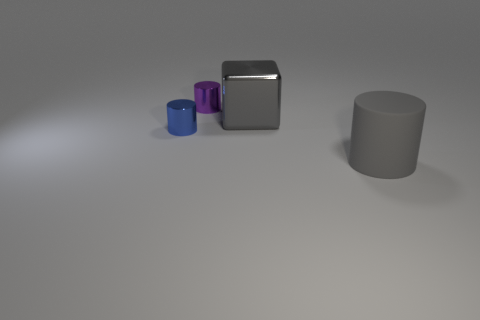Is the number of matte things that are left of the blue shiny cylinder greater than the number of cylinders that are left of the tiny purple object?
Your response must be concise. No. Is the small cylinder behind the large gray metallic object made of the same material as the large object that is behind the tiny blue cylinder?
Make the answer very short. Yes. There is a tiny purple metal thing; are there any tiny purple things on the right side of it?
Provide a succinct answer. No. How many blue things are small metal cylinders or shiny cubes?
Ensure brevity in your answer.  1. Is the material of the purple cylinder the same as the gray object in front of the tiny blue shiny cylinder?
Your response must be concise. No. There is a blue object that is the same shape as the purple shiny thing; what size is it?
Your response must be concise. Small. What is the material of the small blue object?
Ensure brevity in your answer.  Metal. There is a gray cube that is to the left of the large thing that is in front of the tiny cylinder that is in front of the gray cube; what is its material?
Provide a succinct answer. Metal. Is the size of the metallic cube that is to the right of the tiny blue object the same as the purple thing that is behind the big matte thing?
Ensure brevity in your answer.  No. What number of other things are there of the same material as the gray block
Provide a short and direct response. 2. 